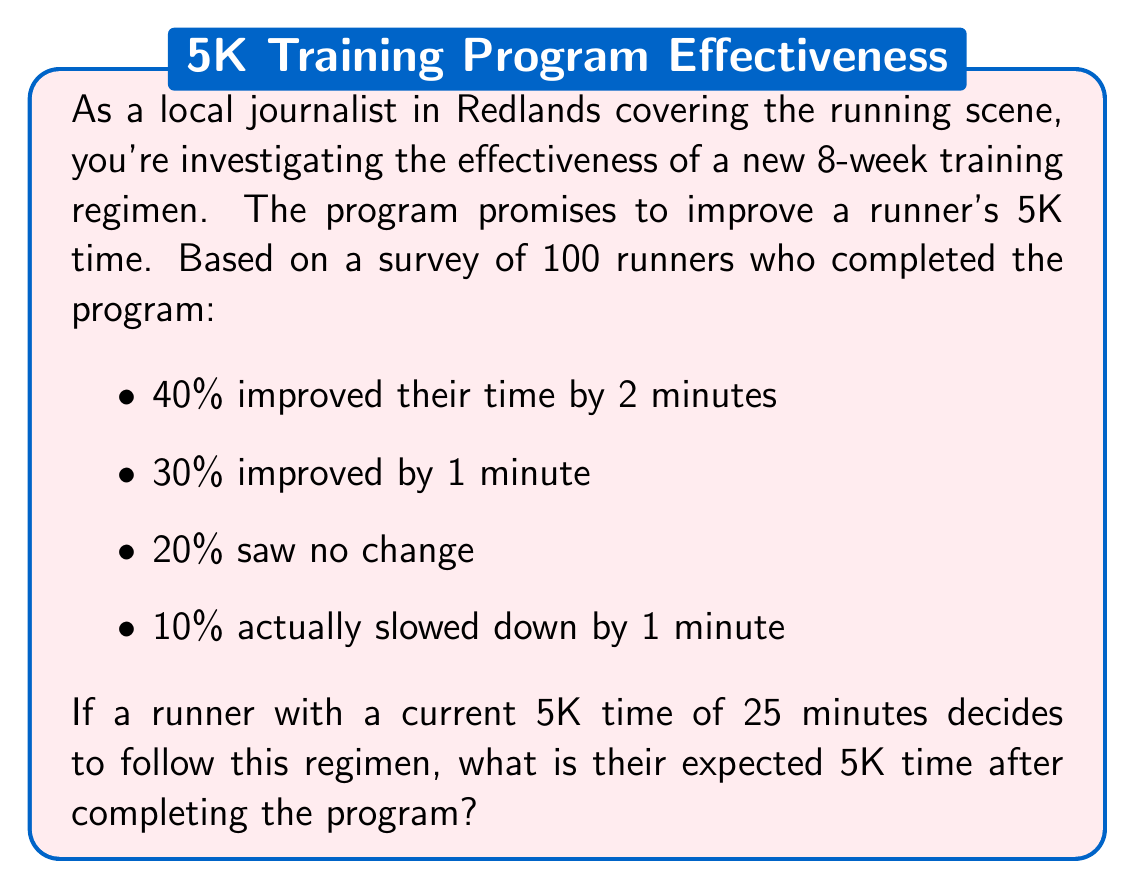Could you help me with this problem? Let's approach this step-by-step:

1) First, we need to calculate the expected improvement in minutes. We'll do this by multiplying each possible outcome by its probability and summing the results.

   $E(\text{improvement}) = (2 \cdot 0.40) + (1 \cdot 0.30) + (0 \cdot 0.20) + (-1 \cdot 0.10)$

2) Let's calculate each term:
   
   $2 \cdot 0.40 = 0.80$
   $1 \cdot 0.30 = 0.30$
   $0 \cdot 0.20 = 0.00$
   $-1 \cdot 0.10 = -0.10$

3) Now, let's sum these values:

   $E(\text{improvement}) = 0.80 + 0.30 + 0.00 + (-0.10) = 1$ minute

4) The expected improvement is 1 minute. Since the runner's current time is 25 minutes, we subtract the expected improvement:

   $\text{Expected new time} = 25 - 1 = 24$ minutes

Therefore, the runner's expected 5K time after completing the program is 24 minutes.
Answer: 24 minutes 